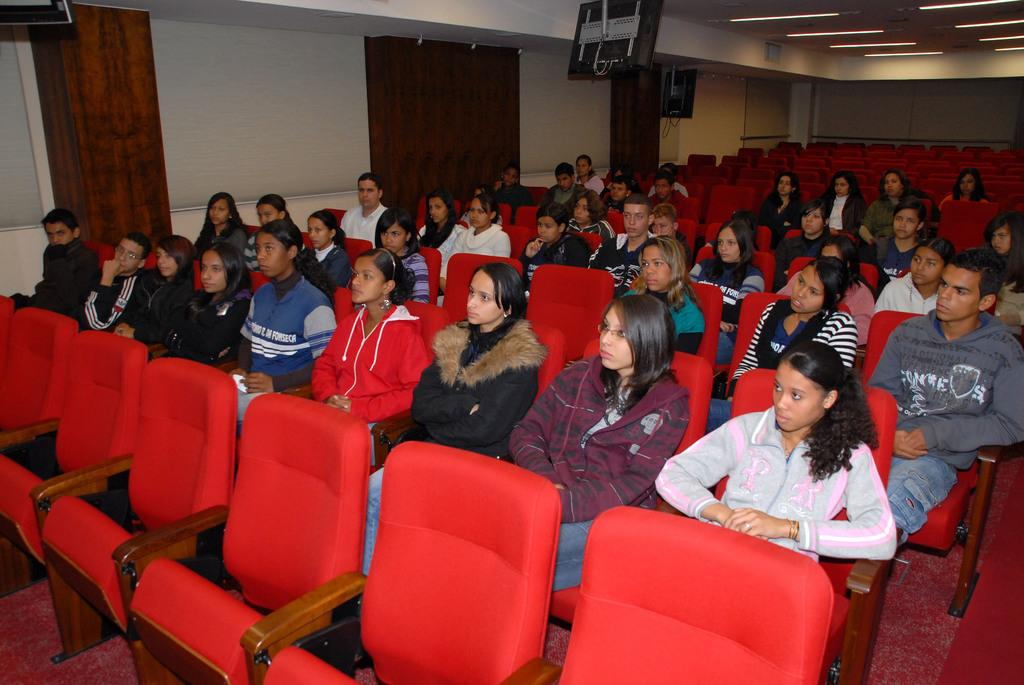What is the color of the wall in the image? The wall in the image is white. What type of window treatment is present in the image? There are curtains in the image. What are the people in the image doing? The people in the image are sitting on chairs. Can you see a fan in the image? There is no fan present in the image. Is there a swing in the image? There is no swing present in the image. 